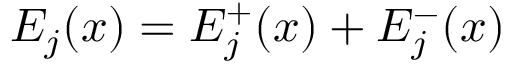<formula> <loc_0><loc_0><loc_500><loc_500>E _ { j } ( x ) = E _ { j } ^ { + } ( x ) + E _ { j } ^ { - } ( x )</formula> 